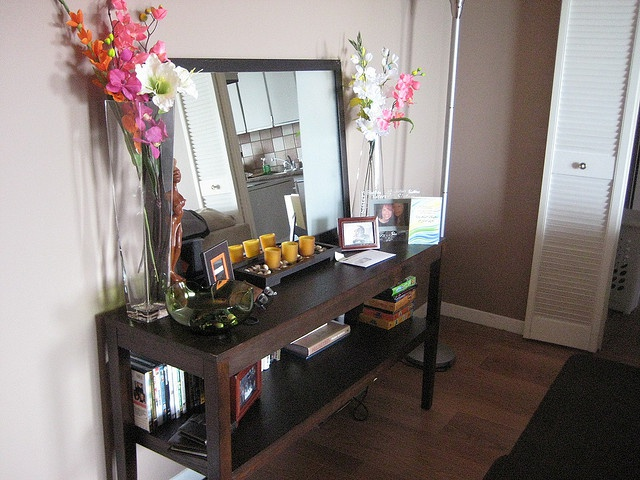Describe the objects in this image and their specific colors. I can see vase in darkgray, gray, lightgray, and black tones, bowl in darkgray, black, darkgreen, and gray tones, couch in darkgray, gray, and black tones, vase in darkgray, lightgray, and gray tones, and book in darkgray, gray, black, and white tones in this image. 